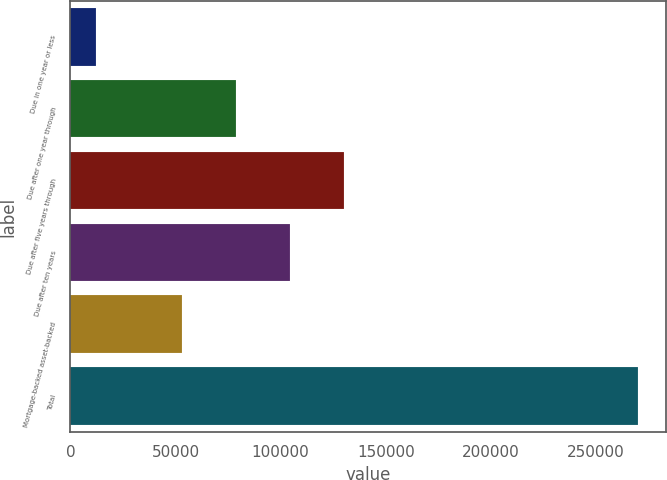Convert chart. <chart><loc_0><loc_0><loc_500><loc_500><bar_chart><fcel>Due in one year or less<fcel>Due after one year through<fcel>Due after five years through<fcel>Due after ten years<fcel>Mortgage-backed asset-backed<fcel>Total<nl><fcel>12001<fcel>78654.8<fcel>130246<fcel>104451<fcel>52859<fcel>269959<nl></chart> 